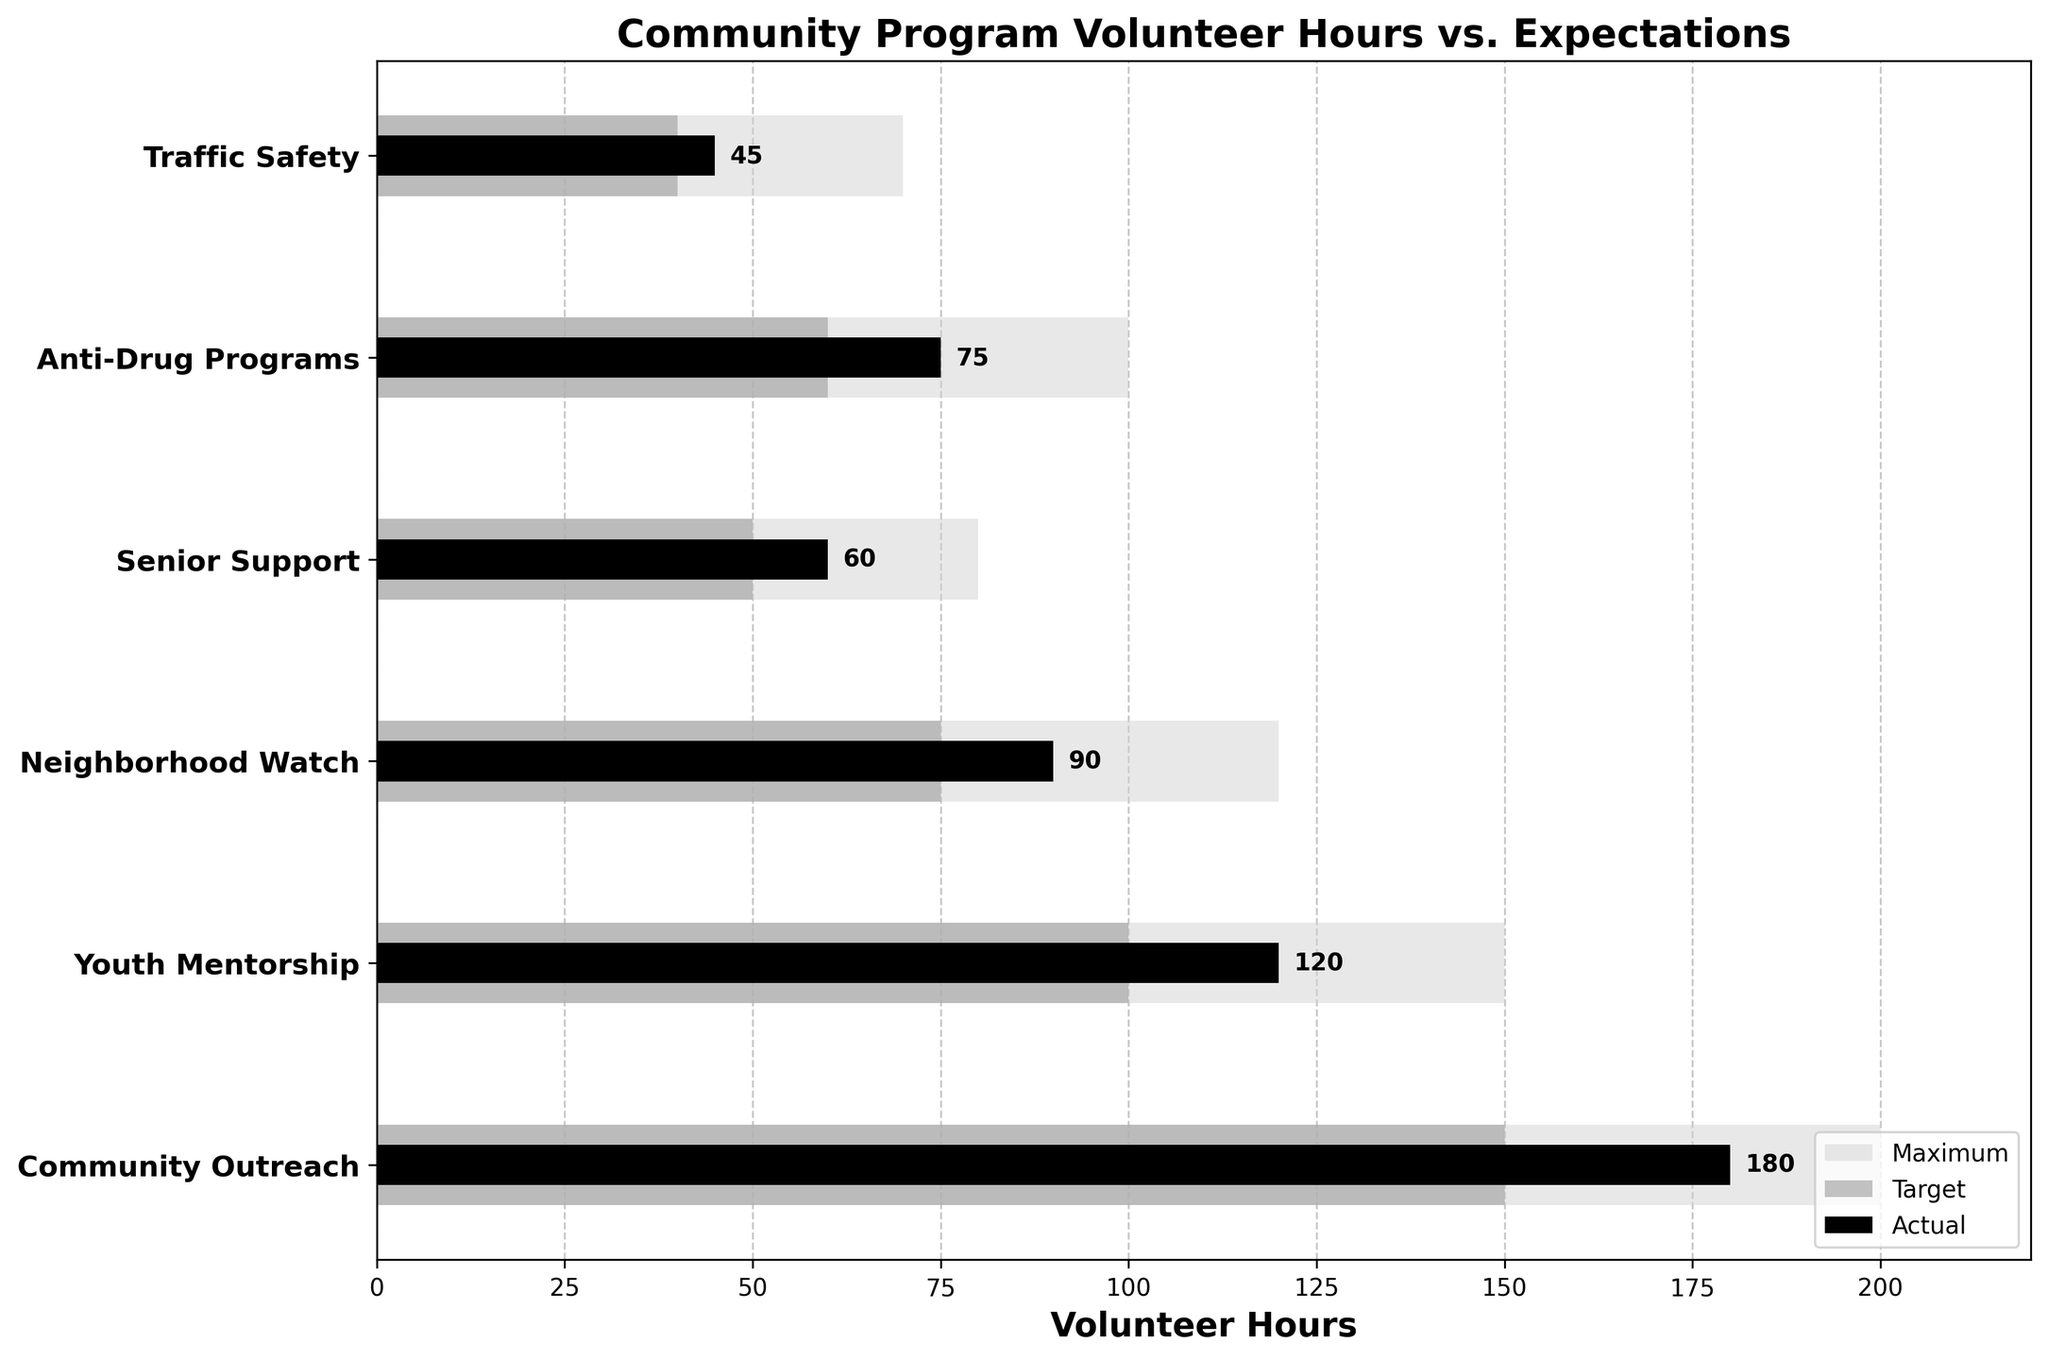What is the title of the chart? The title of the chart is at the top and describes the purpose of the visualization.
Answer: Community Program Volunteer Hours vs. Expectations Which department has the highest actual volunteer hours? The highest actual volunteer hours can be identified by looking at the black bars on the chart.
Answer: Community Outreach What is the target volunteer hours for Youth Mentorship? The target volunteer hours are represented by the darker gray areas. For Youth Mentorship, locate the corresponding bar.
Answer: 100 How many more hours did Community Outreach contribute than its target? Subtract the target hours from the actual hours for Community Outreach (180 - 150).
Answer: 30 Which two departments have the same target hours? Look for departments that have the same length's dark gray bars.
Answer: Senior Support and Traffic Safety List the departments that exceeded their target volunteer hours. Compare the black bars (actual hours) to the dark gray bars (target hours). If the black bar is longer, it exceeded its target.
Answer: Community Outreach, Youth Mentorship, Neighborhood Watch, Anti-Drug Programs What is the average of actual volunteer hours across all departments? Sum the actual hours (180 + 120 + 90 + 60 + 75 + 45) and divide by the number of departments (6).
Answer: 95 Which department has the smallest difference between actual and target hours? Calculate the difference between the actual and target hours for each department, and find the smallest difference.
Answer: Traffic Safety Did any department not reach the target volunteer hours? Compare each department's actual hours to the target hours. Identify any black bars shorter than the dark gray bars.
Answer: None How far from the maximum volunteer hours is the actual contribution in Senior Support? Subtract Senior Support’s actual hours from its maximum hours (80 - 60).
Answer: 20 